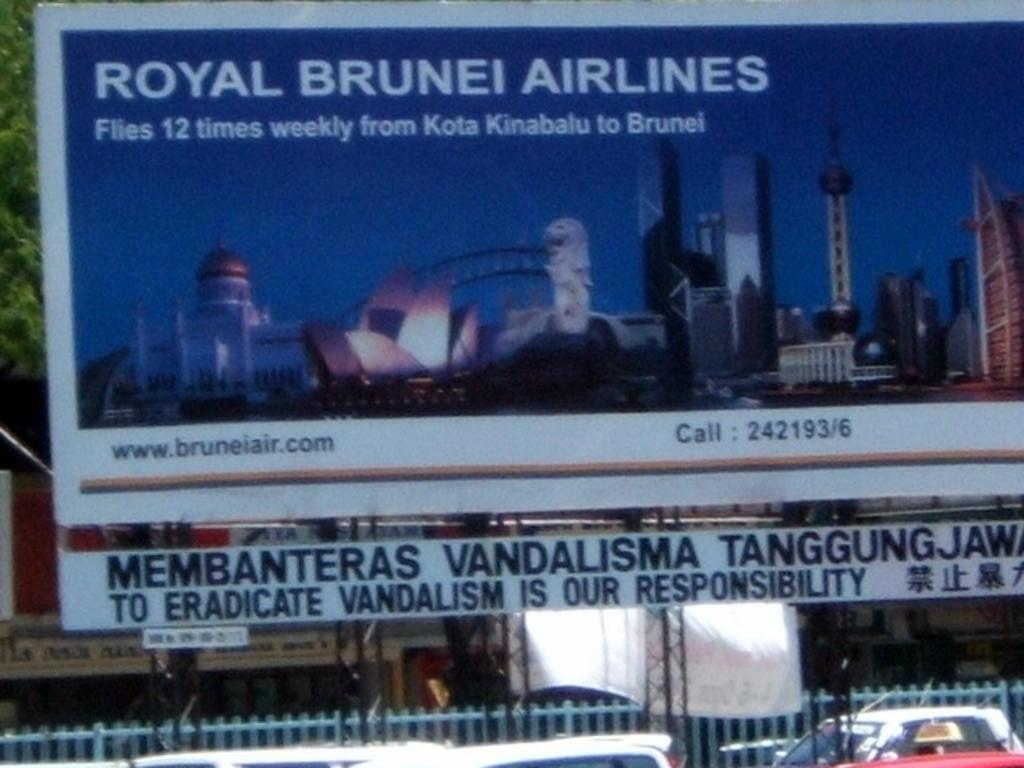<image>
Share a concise interpretation of the image provided. The ad board is for Royal Brunei Airlines 